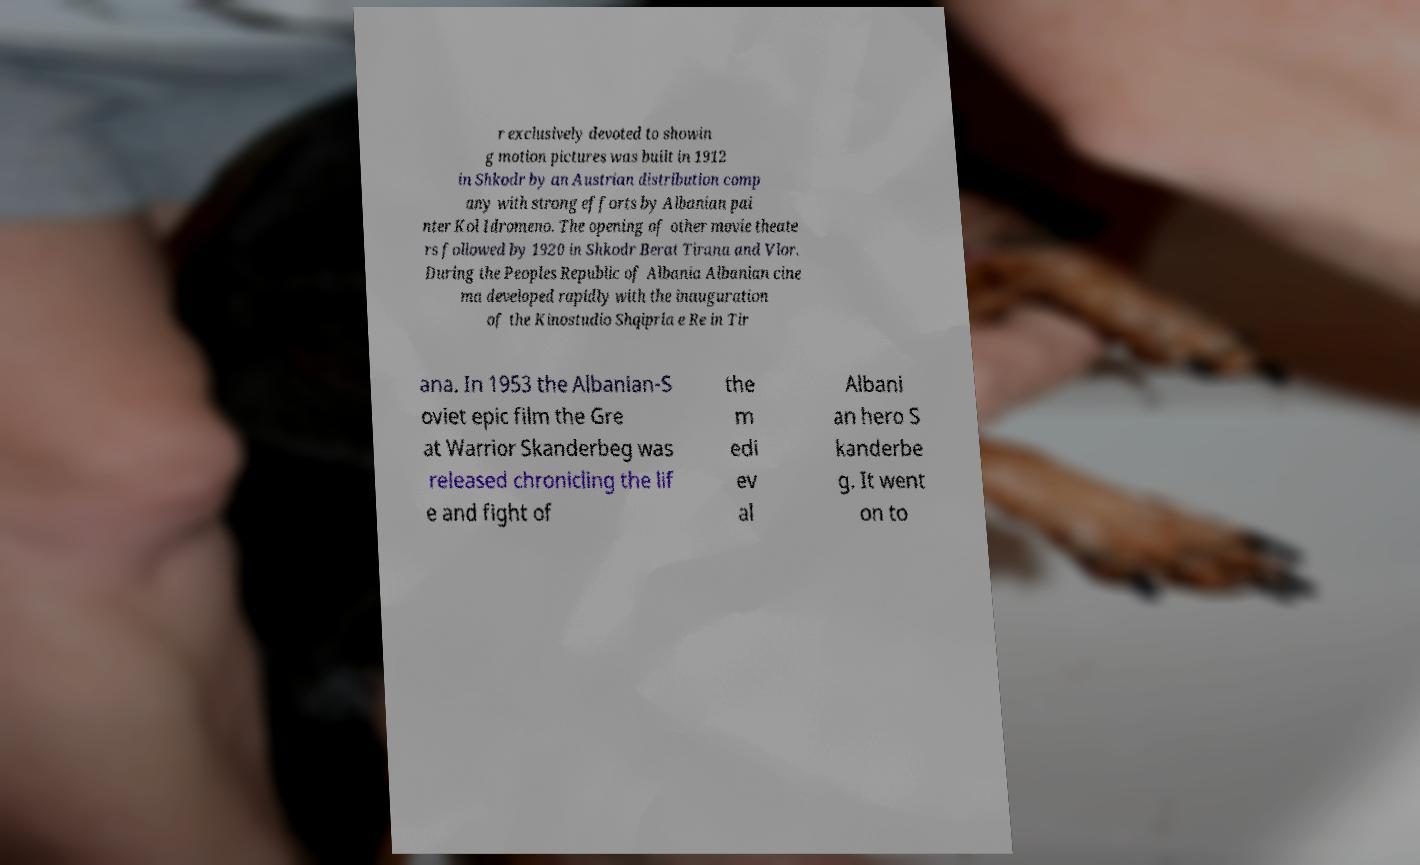There's text embedded in this image that I need extracted. Can you transcribe it verbatim? r exclusively devoted to showin g motion pictures was built in 1912 in Shkodr by an Austrian distribution comp any with strong efforts by Albanian pai nter Kol Idromeno. The opening of other movie theate rs followed by 1920 in Shkodr Berat Tirana and Vlor. During the Peoples Republic of Albania Albanian cine ma developed rapidly with the inauguration of the Kinostudio Shqipria e Re in Tir ana. In 1953 the Albanian-S oviet epic film the Gre at Warrior Skanderbeg was released chronicling the lif e and fight of the m edi ev al Albani an hero S kanderbe g. It went on to 